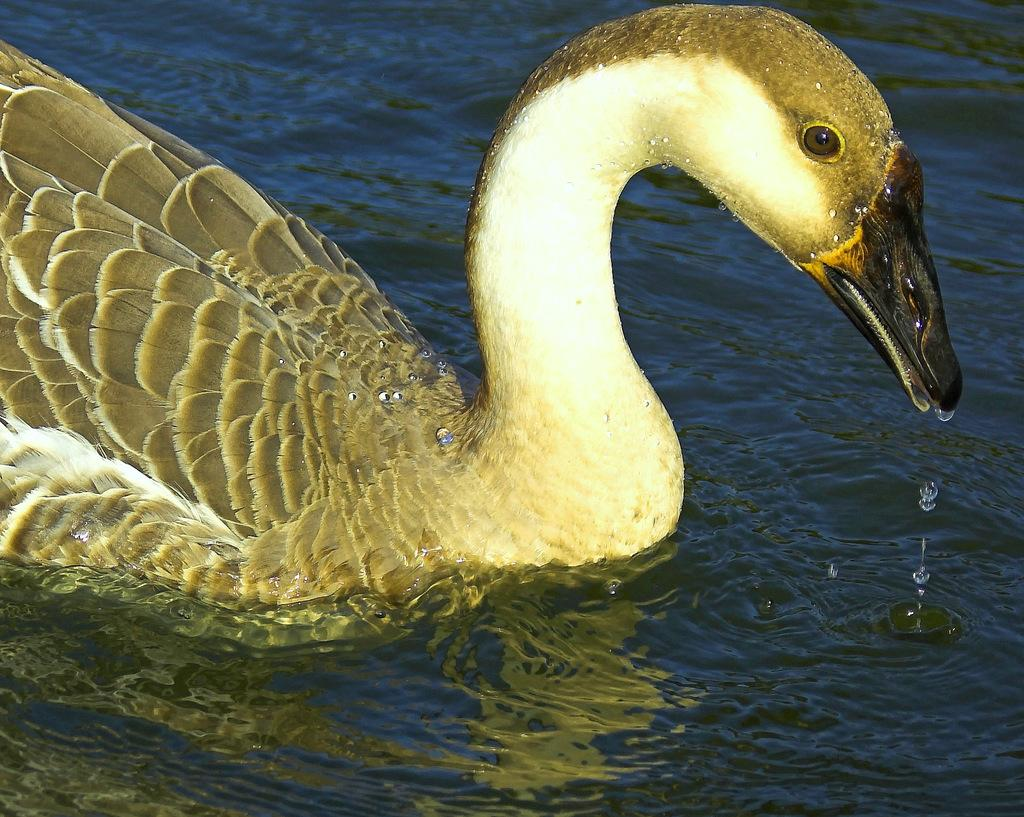What type of animal can be seen in the image? There is a bird in the image. Where is the bird located in the image? The bird is on the surface of the water. What type of dolls can be seen floating in the bird's stomach in the image? There are no dolls present in the image, and the bird's stomach is not visible. What color is the ink that the bird is using to write in the image? There is no ink or writing present in the image. 